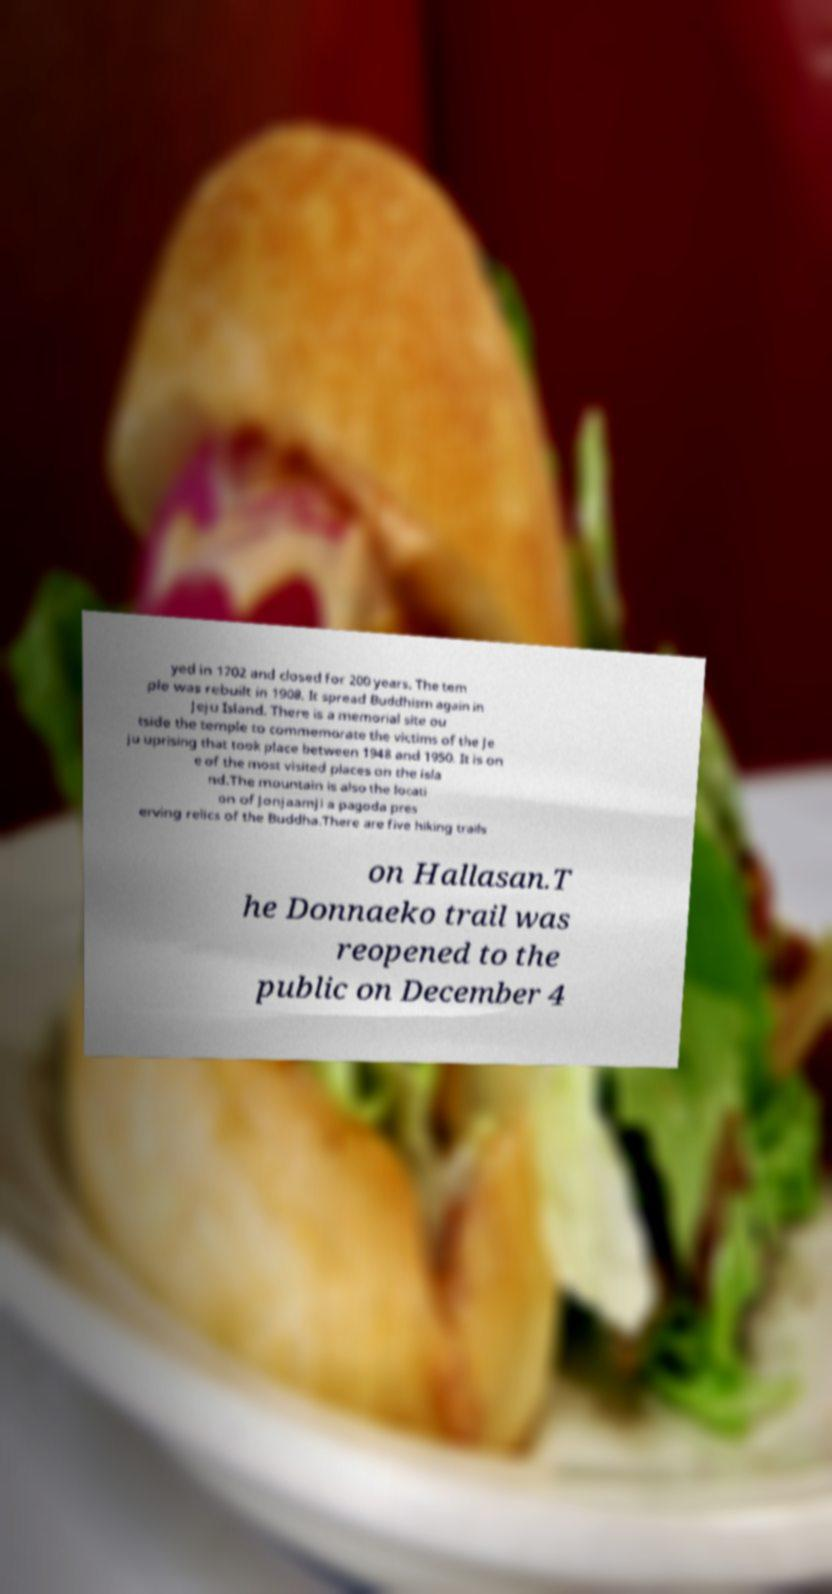I need the written content from this picture converted into text. Can you do that? yed in 1702 and closed for 200 years. The tem ple was rebuilt in 1908. It spread Buddhism again in Jeju Island. There is a memorial site ou tside the temple to commemorate the victims of the Je ju uprising that took place between 1948 and 1950. It is on e of the most visited places on the isla nd.The mountain is also the locati on of Jonjaamji a pagoda pres erving relics of the Buddha.There are five hiking trails on Hallasan.T he Donnaeko trail was reopened to the public on December 4 